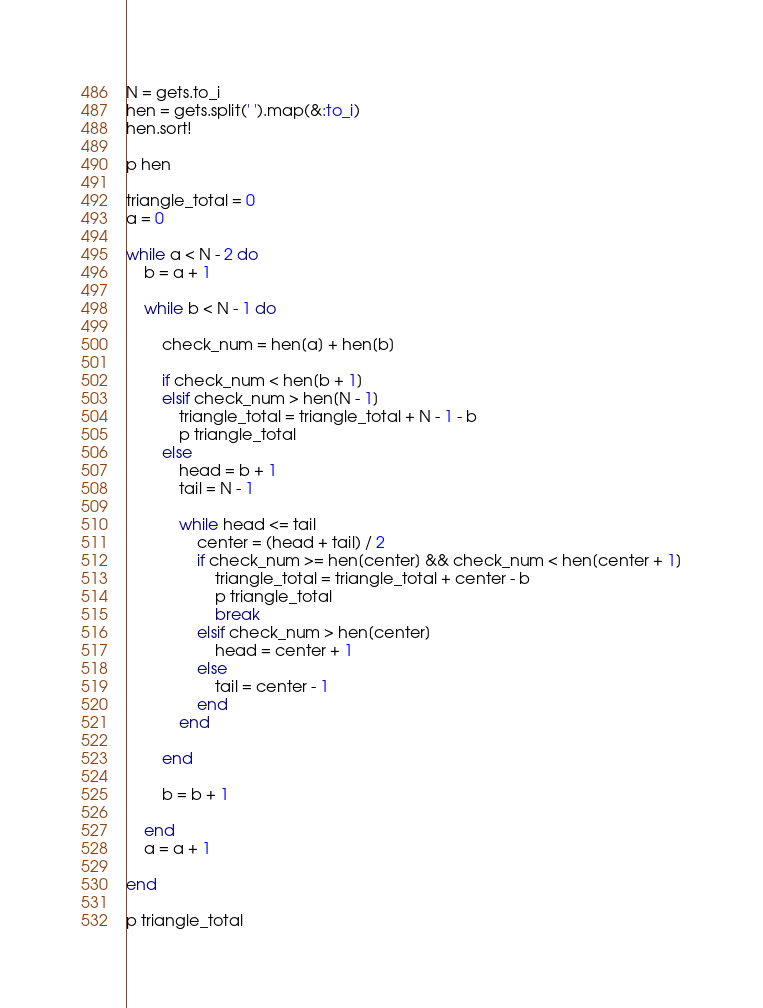Convert code to text. <code><loc_0><loc_0><loc_500><loc_500><_Ruby_>N = gets.to_i
hen = gets.split(' ').map(&:to_i)
hen.sort!

p hen

triangle_total = 0
a = 0

while a < N - 2 do
    b = a + 1

    while b < N - 1 do 
        
        check_num = hen[a] + hen[b]
        
        if check_num < hen[b + 1]
        elsif check_num > hen[N - 1]
            triangle_total = triangle_total + N - 1 - b
            p triangle_total
        else
            head = b + 1
            tail = N - 1

            while head <= tail
                center = (head + tail) / 2                
                if check_num >= hen[center] && check_num < hen[center + 1]
                    triangle_total = triangle_total + center - b
                    p triangle_total
                    break
                elsif check_num > hen[center]
                    head = center + 1
                else
                    tail = center - 1
                end
            end

        end

        b = b + 1

    end
    a = a + 1

end

p triangle_total
</code> 